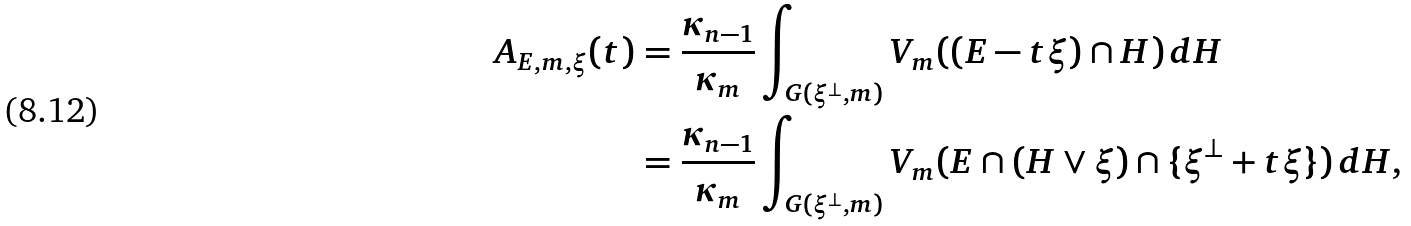<formula> <loc_0><loc_0><loc_500><loc_500>A _ { E , m , \xi } ( t ) & = \frac { \kappa _ { n - 1 } } { \kappa _ { m } } \int _ { G ( \xi ^ { \perp } , m ) } V _ { m } ( ( E - t \xi ) \cap H ) \, d H \\ & = \frac { \kappa _ { n - 1 } } { \kappa _ { m } } \int _ { G ( \xi ^ { \perp } , m ) } V _ { m } ( E \cap ( H \vee \xi ) \cap \{ \xi ^ { \perp } + t \xi \} ) \, d H ,</formula> 